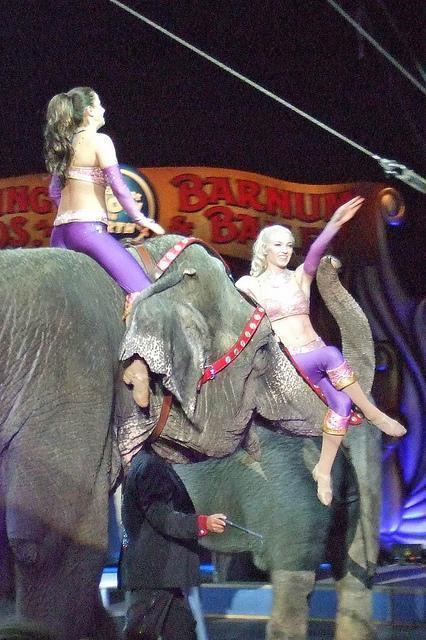How many elephants do you see?
Give a very brief answer. 2. How many people are there?
Give a very brief answer. 3. How many elephants are visible?
Give a very brief answer. 2. 